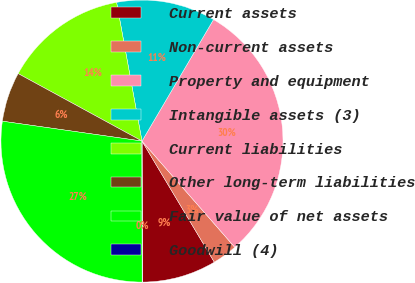<chart> <loc_0><loc_0><loc_500><loc_500><pie_chart><fcel>Current assets<fcel>Non-current assets<fcel>Property and equipment<fcel>Intangible assets (3)<fcel>Current liabilities<fcel>Other long-term liabilities<fcel>Fair value of net assets<fcel>Goodwill (4)<nl><fcel>8.52%<fcel>2.86%<fcel>30.1%<fcel>11.35%<fcel>14.18%<fcel>5.69%<fcel>27.27%<fcel>0.03%<nl></chart> 